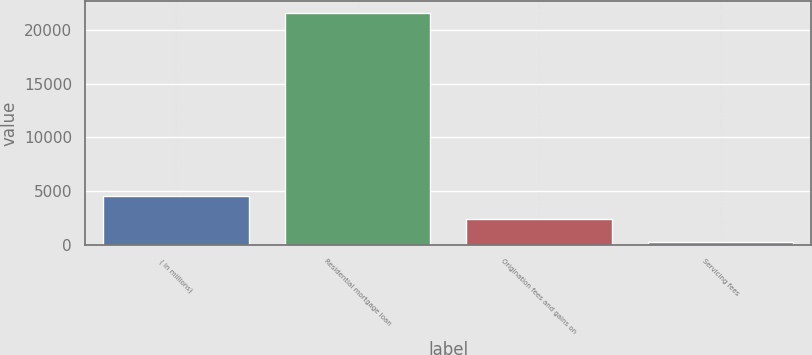Convert chart to OTSL. <chart><loc_0><loc_0><loc_500><loc_500><bar_chart><fcel>( in millions)<fcel>Residential mortgage loan<fcel>Origination fees and gains on<fcel>Servicing fees<nl><fcel>4514.8<fcel>21574<fcel>2382.4<fcel>250<nl></chart> 